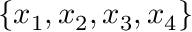<formula> <loc_0><loc_0><loc_500><loc_500>\{ x _ { 1 } , x _ { 2 } , x _ { 3 } , x _ { 4 } \}</formula> 